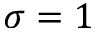<formula> <loc_0><loc_0><loc_500><loc_500>\sigma = 1</formula> 